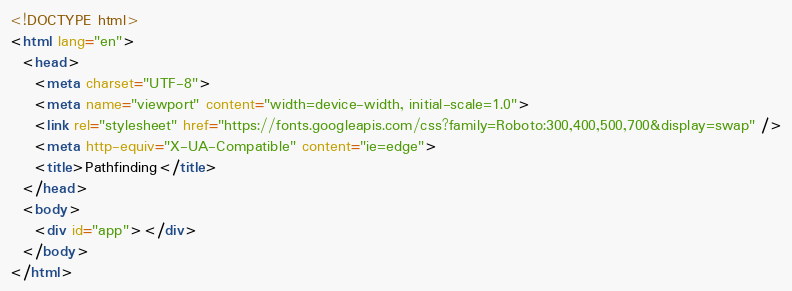Convert code to text. <code><loc_0><loc_0><loc_500><loc_500><_HTML_><!DOCTYPE html>
<html lang="en">
  <head>
    <meta charset="UTF-8">
    <meta name="viewport" content="width=device-width, initial-scale=1.0">
    <link rel="stylesheet" href="https://fonts.googleapis.com/css?family=Roboto:300,400,500,700&display=swap" />
    <meta http-equiv="X-UA-Compatible" content="ie=edge">
    <title>Pathfinding</title>
  </head>
  <body>
    <div id="app"></div>
  </body>
</html></code> 